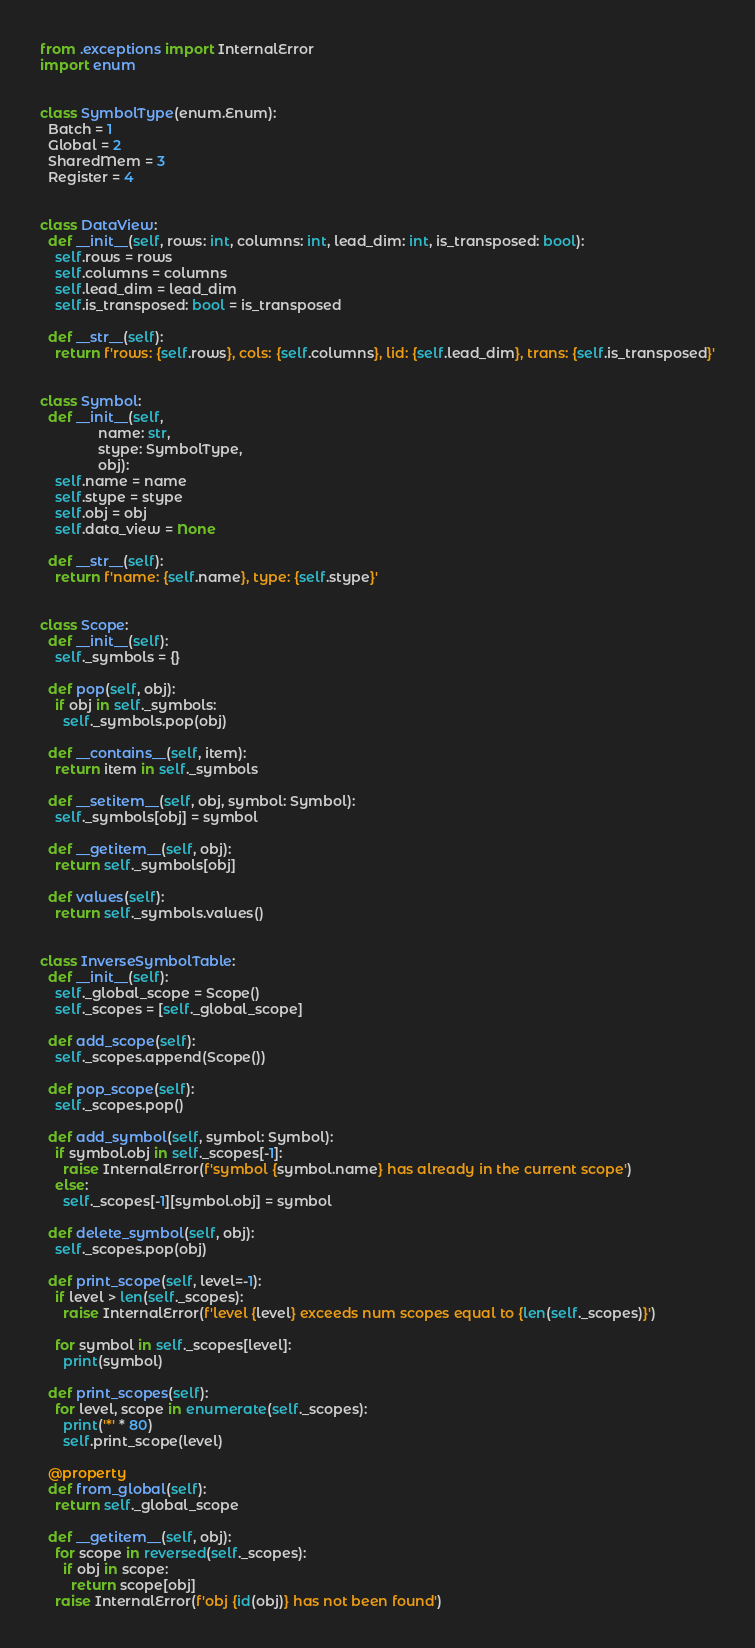<code> <loc_0><loc_0><loc_500><loc_500><_Python_>from .exceptions import InternalError
import enum


class SymbolType(enum.Enum):
  Batch = 1
  Global = 2
  SharedMem = 3
  Register = 4


class DataView:
  def __init__(self, rows: int, columns: int, lead_dim: int, is_transposed: bool):
    self.rows = rows
    self.columns = columns
    self.lead_dim = lead_dim
    self.is_transposed: bool = is_transposed

  def __str__(self):
    return f'rows: {self.rows}, cols: {self.columns}, lid: {self.lead_dim}, trans: {self.is_transposed}'


class Symbol:
  def __init__(self,
               name: str,
               stype: SymbolType,
               obj):
    self.name = name
    self.stype = stype
    self.obj = obj
    self.data_view = None

  def __str__(self):
    return f'name: {self.name}, type: {self.stype}'


class Scope:
  def __init__(self):
    self._symbols = {}

  def pop(self, obj):
    if obj in self._symbols:
      self._symbols.pop(obj)

  def __contains__(self, item):
    return item in self._symbols

  def __setitem__(self, obj, symbol: Symbol):
    self._symbols[obj] = symbol

  def __getitem__(self, obj):
    return self._symbols[obj]

  def values(self):
    return self._symbols.values()


class InverseSymbolTable:
  def __init__(self):
    self._global_scope = Scope()
    self._scopes = [self._global_scope]

  def add_scope(self):
    self._scopes.append(Scope())

  def pop_scope(self):
    self._scopes.pop()

  def add_symbol(self, symbol: Symbol):
    if symbol.obj in self._scopes[-1]:
      raise InternalError(f'symbol {symbol.name} has already in the current scope')
    else:
      self._scopes[-1][symbol.obj] = symbol

  def delete_symbol(self, obj):
    self._scopes.pop(obj)

  def print_scope(self, level=-1):
    if level > len(self._scopes):
      raise InternalError(f'level {level} exceeds num scopes equal to {len(self._scopes)}')

    for symbol in self._scopes[level]:
      print(symbol)

  def print_scopes(self):
    for level, scope in enumerate(self._scopes):
      print('*' * 80)
      self.print_scope(level)

  @property
  def from_global(self):
    return self._global_scope

  def __getitem__(self, obj):
    for scope in reversed(self._scopes):
      if obj in scope:
        return scope[obj]
    raise InternalError(f'obj {id(obj)} has not been found')
</code> 